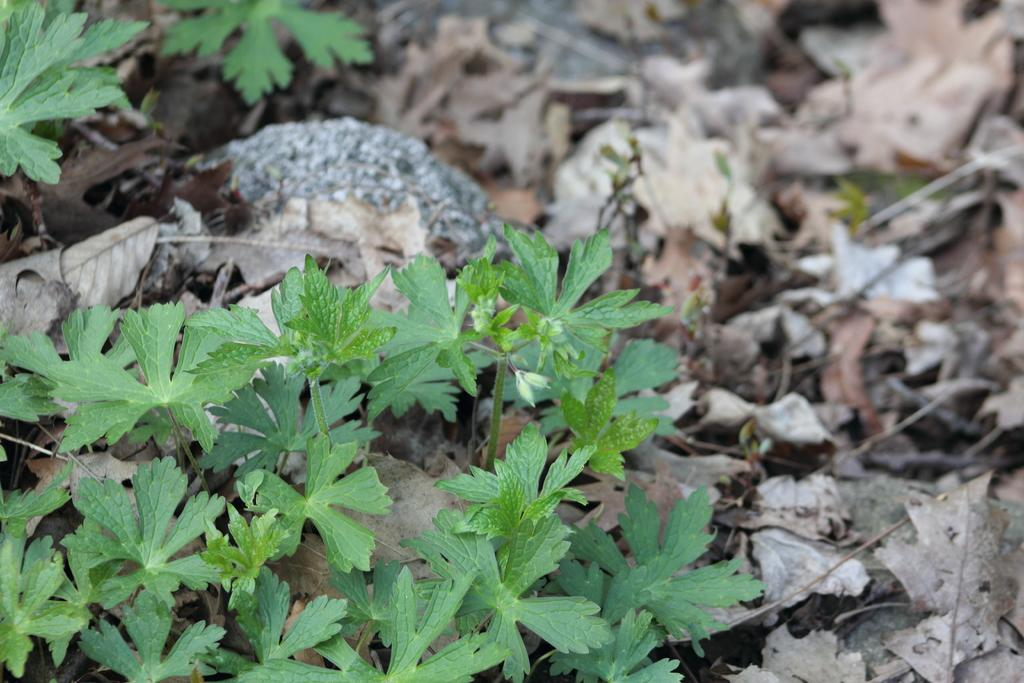What type of natural elements can be seen in the image? There are leaves and rocks in the image. What is the condition of the leaves on the surface in the image? The leaves on the surface in the image are dry. What type of frame is used to enhance the acoustics in the image? There is no frame or acoustics enhancement present in the image; it features leaves and rocks. 